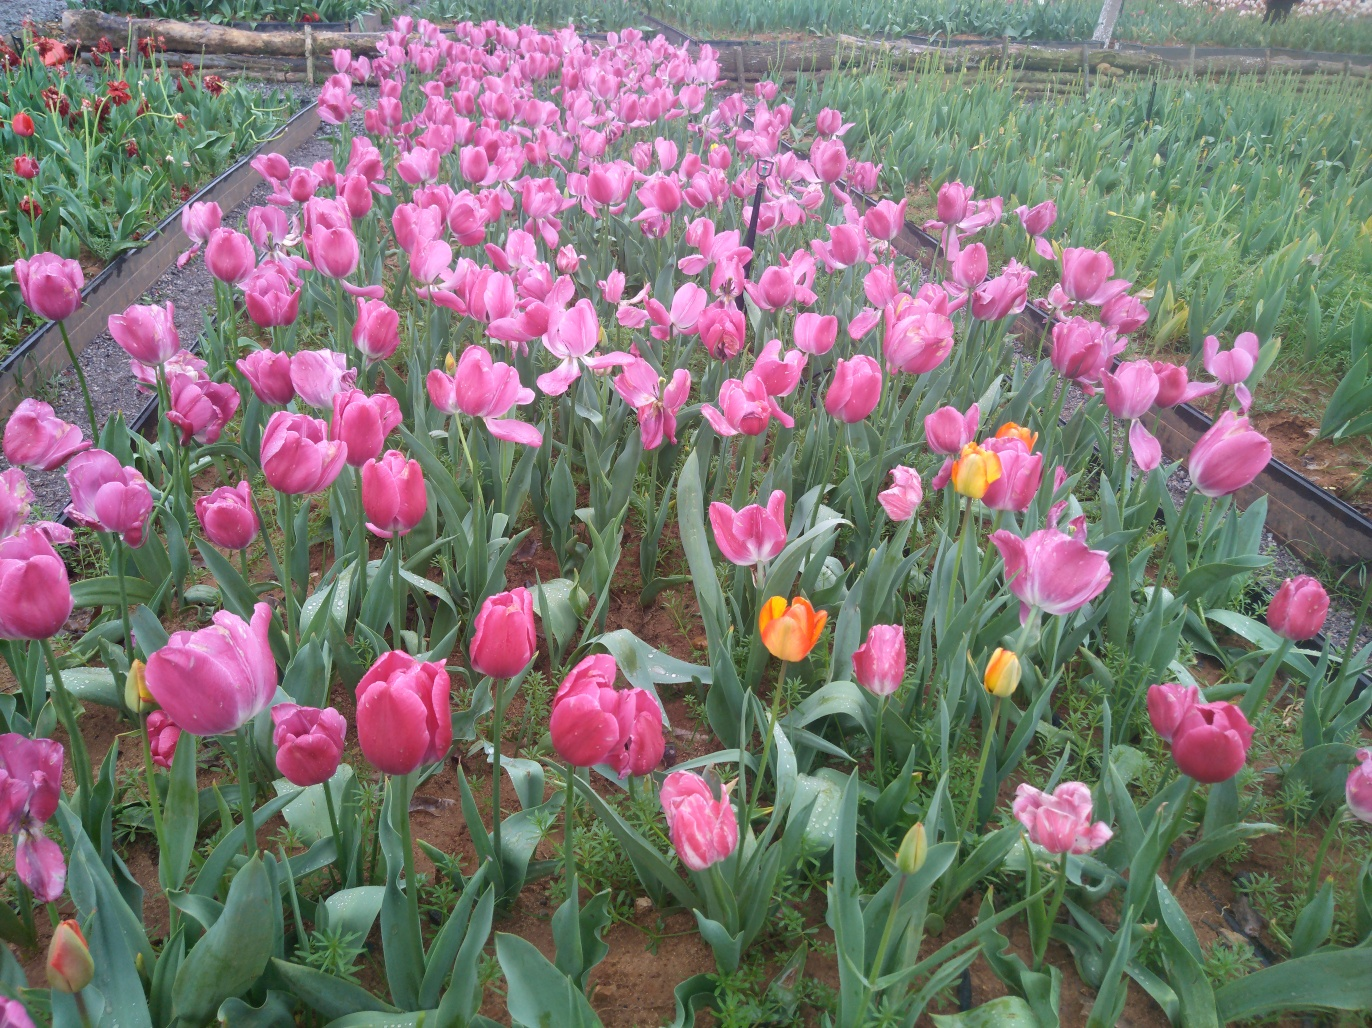Can you describe the variety of colors present in the tulips shown in the image? Certainly! The majority of tulips featured in the image display a beautiful shade of pink, ranging from soft, pastel hues to more intense and deep pink tones. Interspersed among the pink tulips, we can also observe a few tulips with vibrant orange and yellow petals, providing a delightful contrast that enhances the visual appeal of the scene. 